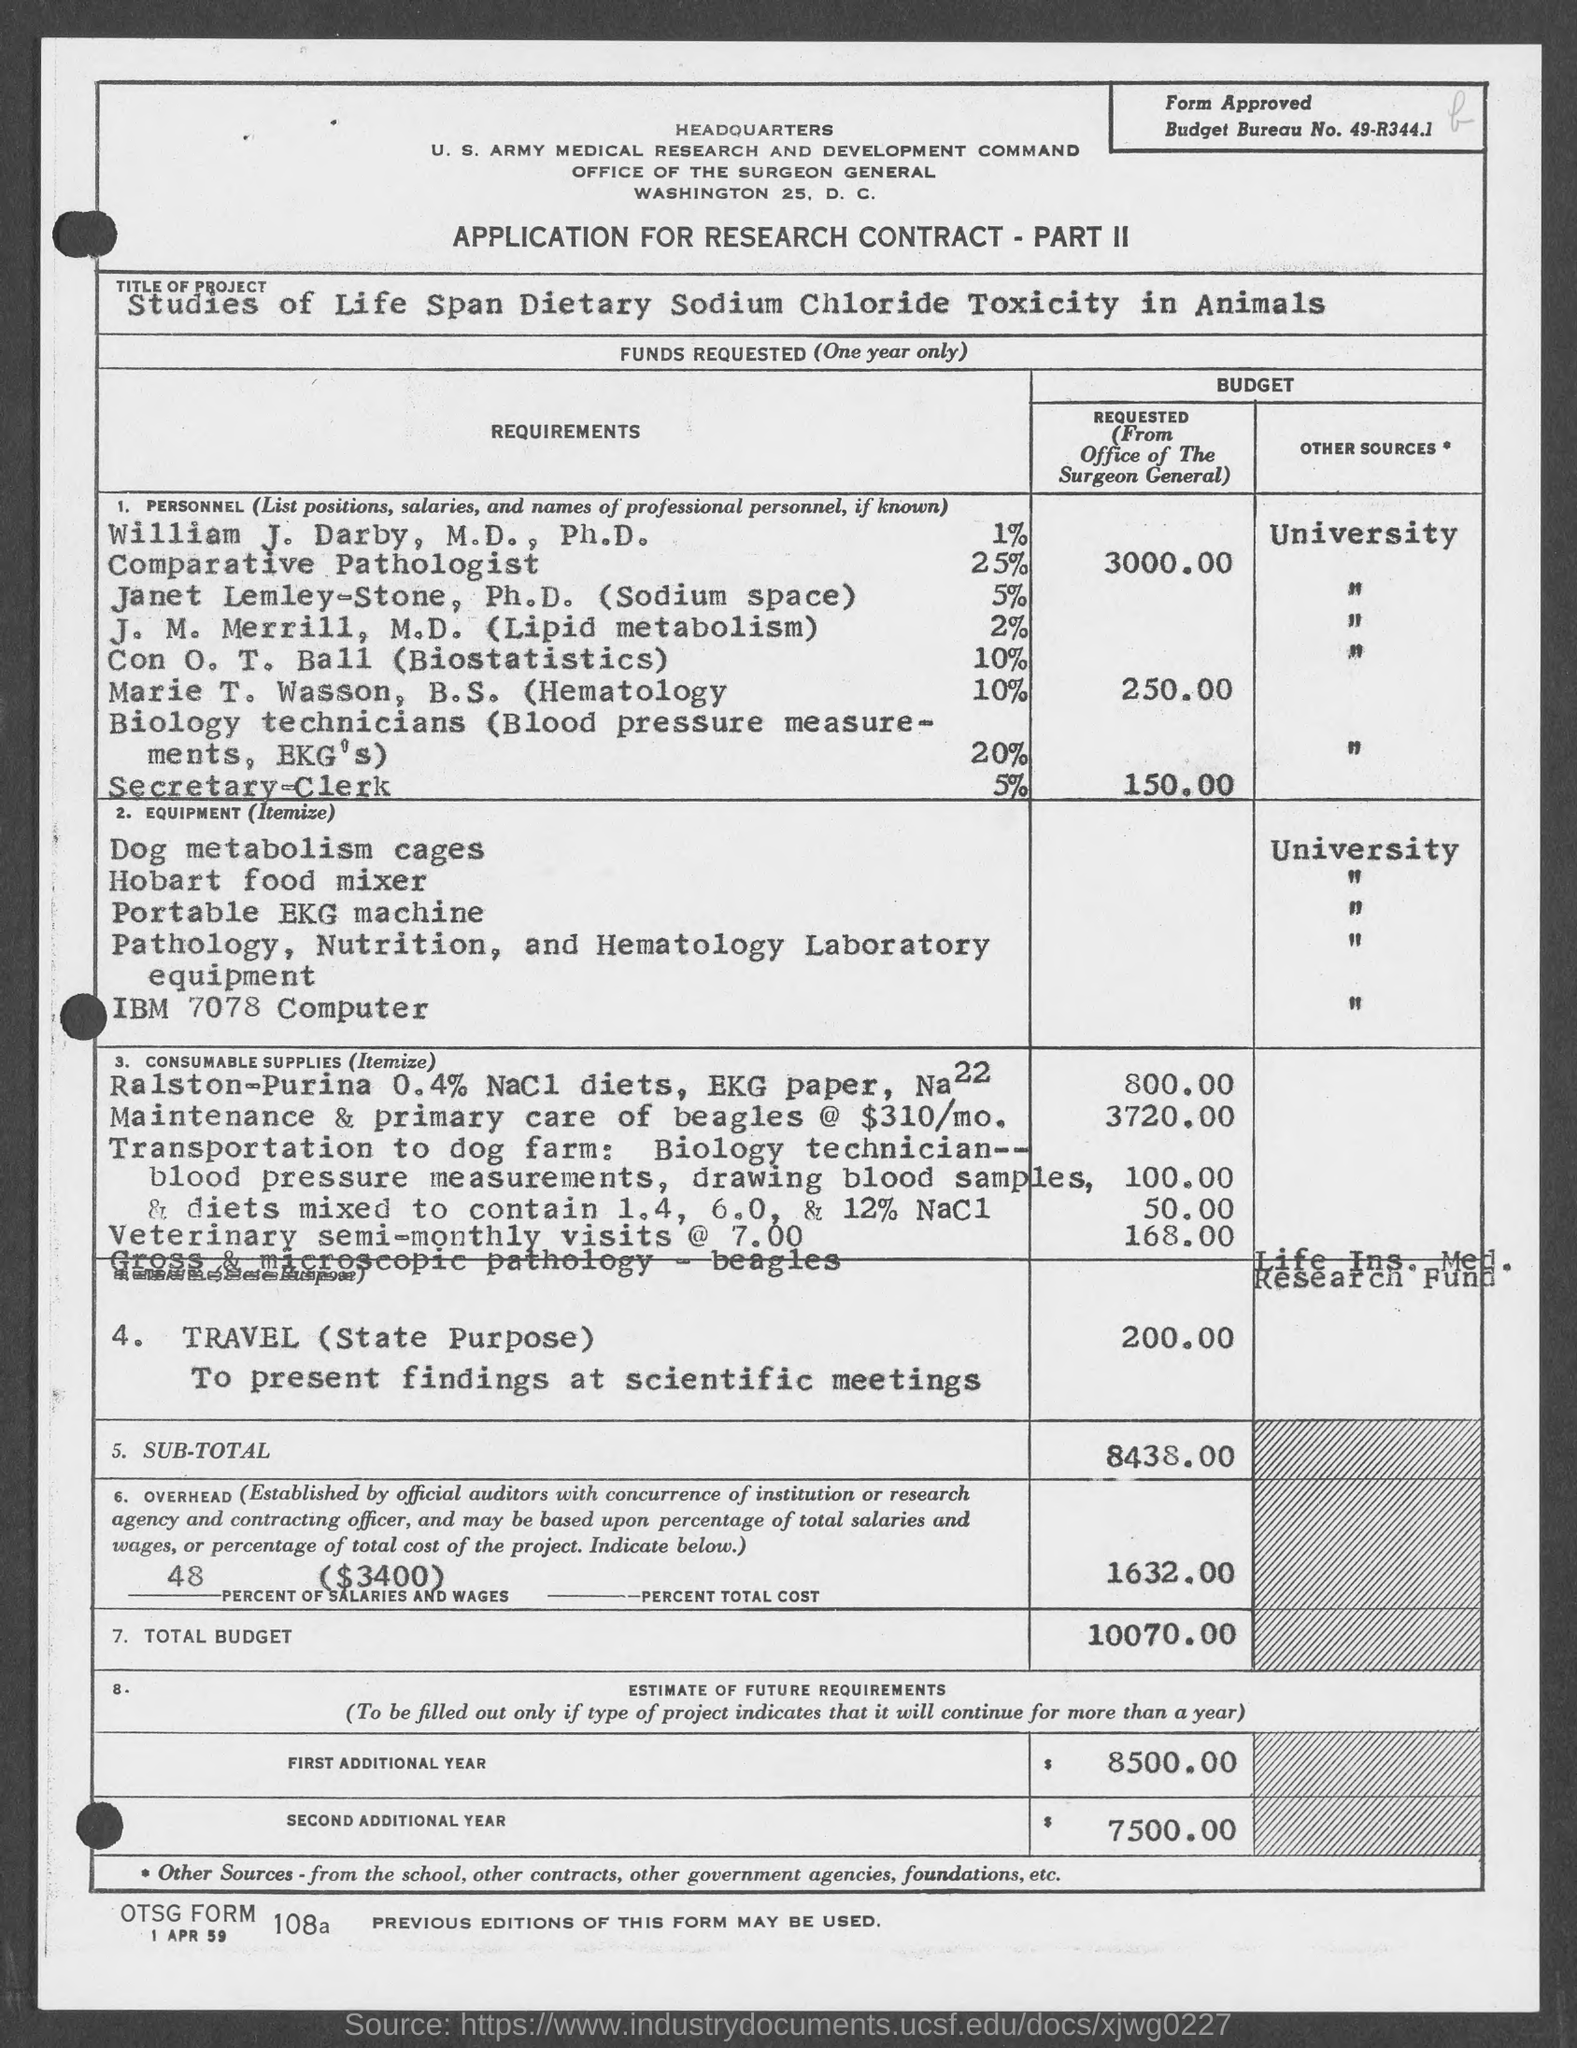Specify some key components in this picture. The budget bureau number is 49-R344.1. 